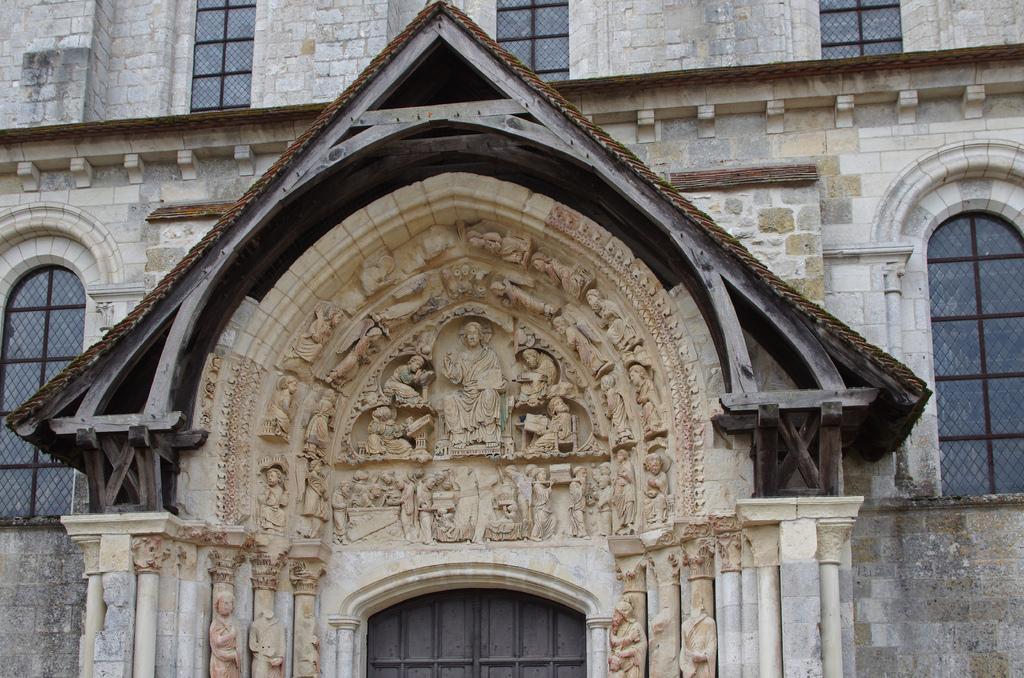Could you give a brief overview of what you see in this image? In this image in the front there are sculptures. In the background there is a building and there are windows. 